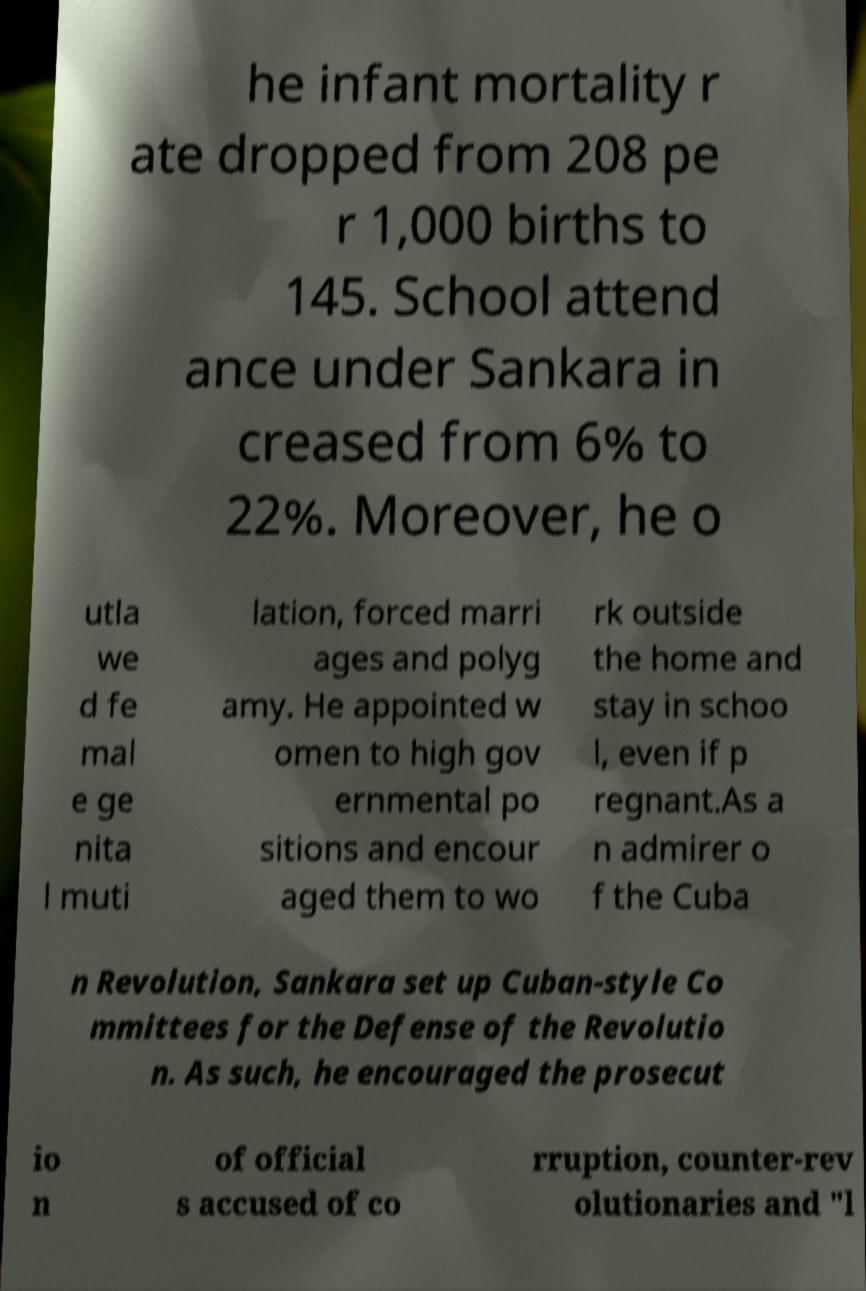For documentation purposes, I need the text within this image transcribed. Could you provide that? he infant mortality r ate dropped from 208 pe r 1,000 births to 145. School attend ance under Sankara in creased from 6% to 22%. Moreover, he o utla we d fe mal e ge nita l muti lation, forced marri ages and polyg amy. He appointed w omen to high gov ernmental po sitions and encour aged them to wo rk outside the home and stay in schoo l, even if p regnant.As a n admirer o f the Cuba n Revolution, Sankara set up Cuban-style Co mmittees for the Defense of the Revolutio n. As such, he encouraged the prosecut io n of official s accused of co rruption, counter-rev olutionaries and "l 